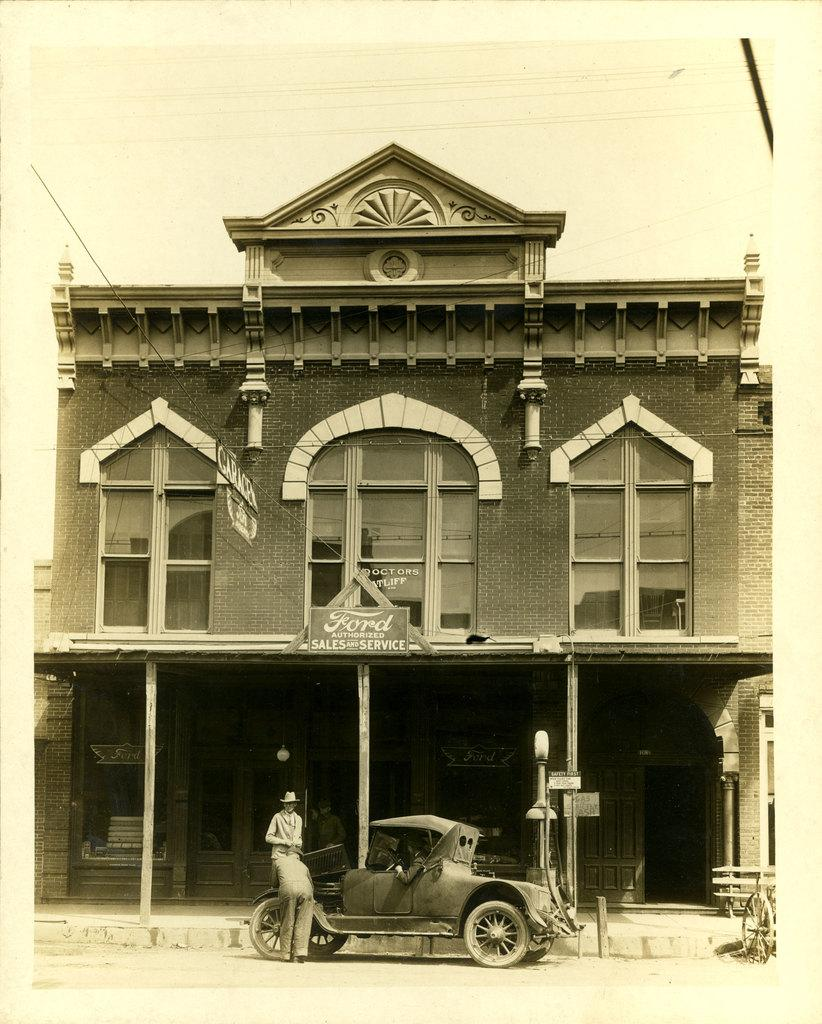How many people are in the image? There are two persons in the image. What are the persons doing in the image? The persons are near a car. What can be seen in the background of the image? There is a building and a name board in the background of the image. What is visible in the sky in the image? The sky is visible in the background of the image. What type of sofa can be seen floating in space in the image? There is no sofa or space present in the image; it features two persons near a car with a building and name board in the background. 